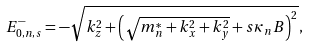Convert formula to latex. <formula><loc_0><loc_0><loc_500><loc_500>E _ { 0 , n , s } ^ { - } = - \sqrt { k _ { z } ^ { 2 } + \left ( \sqrt { m _ { n } ^ { * } + k _ { x } ^ { 2 } + k _ { y } ^ { 2 } } + s \kappa _ { n } B \right ) ^ { 2 } } \, ,</formula> 